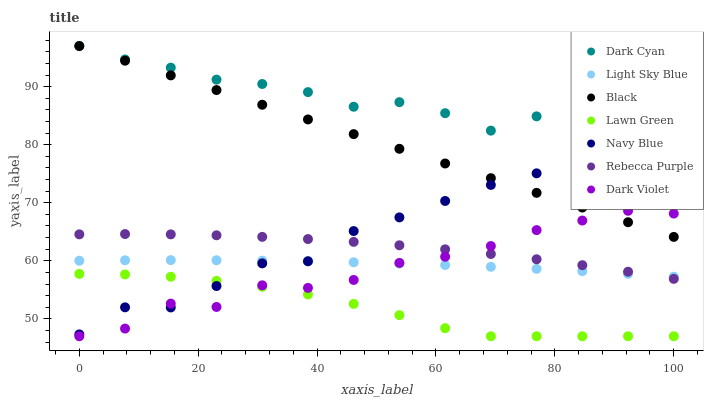Does Lawn Green have the minimum area under the curve?
Answer yes or no. Yes. Does Dark Cyan have the maximum area under the curve?
Answer yes or no. Yes. Does Navy Blue have the minimum area under the curve?
Answer yes or no. No. Does Navy Blue have the maximum area under the curve?
Answer yes or no. No. Is Black the smoothest?
Answer yes or no. Yes. Is Navy Blue the roughest?
Answer yes or no. Yes. Is Dark Violet the smoothest?
Answer yes or no. No. Is Dark Violet the roughest?
Answer yes or no. No. Does Lawn Green have the lowest value?
Answer yes or no. Yes. Does Navy Blue have the lowest value?
Answer yes or no. No. Does Dark Cyan have the highest value?
Answer yes or no. Yes. Does Navy Blue have the highest value?
Answer yes or no. No. Is Rebecca Purple less than Dark Cyan?
Answer yes or no. Yes. Is Dark Cyan greater than Rebecca Purple?
Answer yes or no. Yes. Does Light Sky Blue intersect Dark Violet?
Answer yes or no. Yes. Is Light Sky Blue less than Dark Violet?
Answer yes or no. No. Is Light Sky Blue greater than Dark Violet?
Answer yes or no. No. Does Rebecca Purple intersect Dark Cyan?
Answer yes or no. No. 